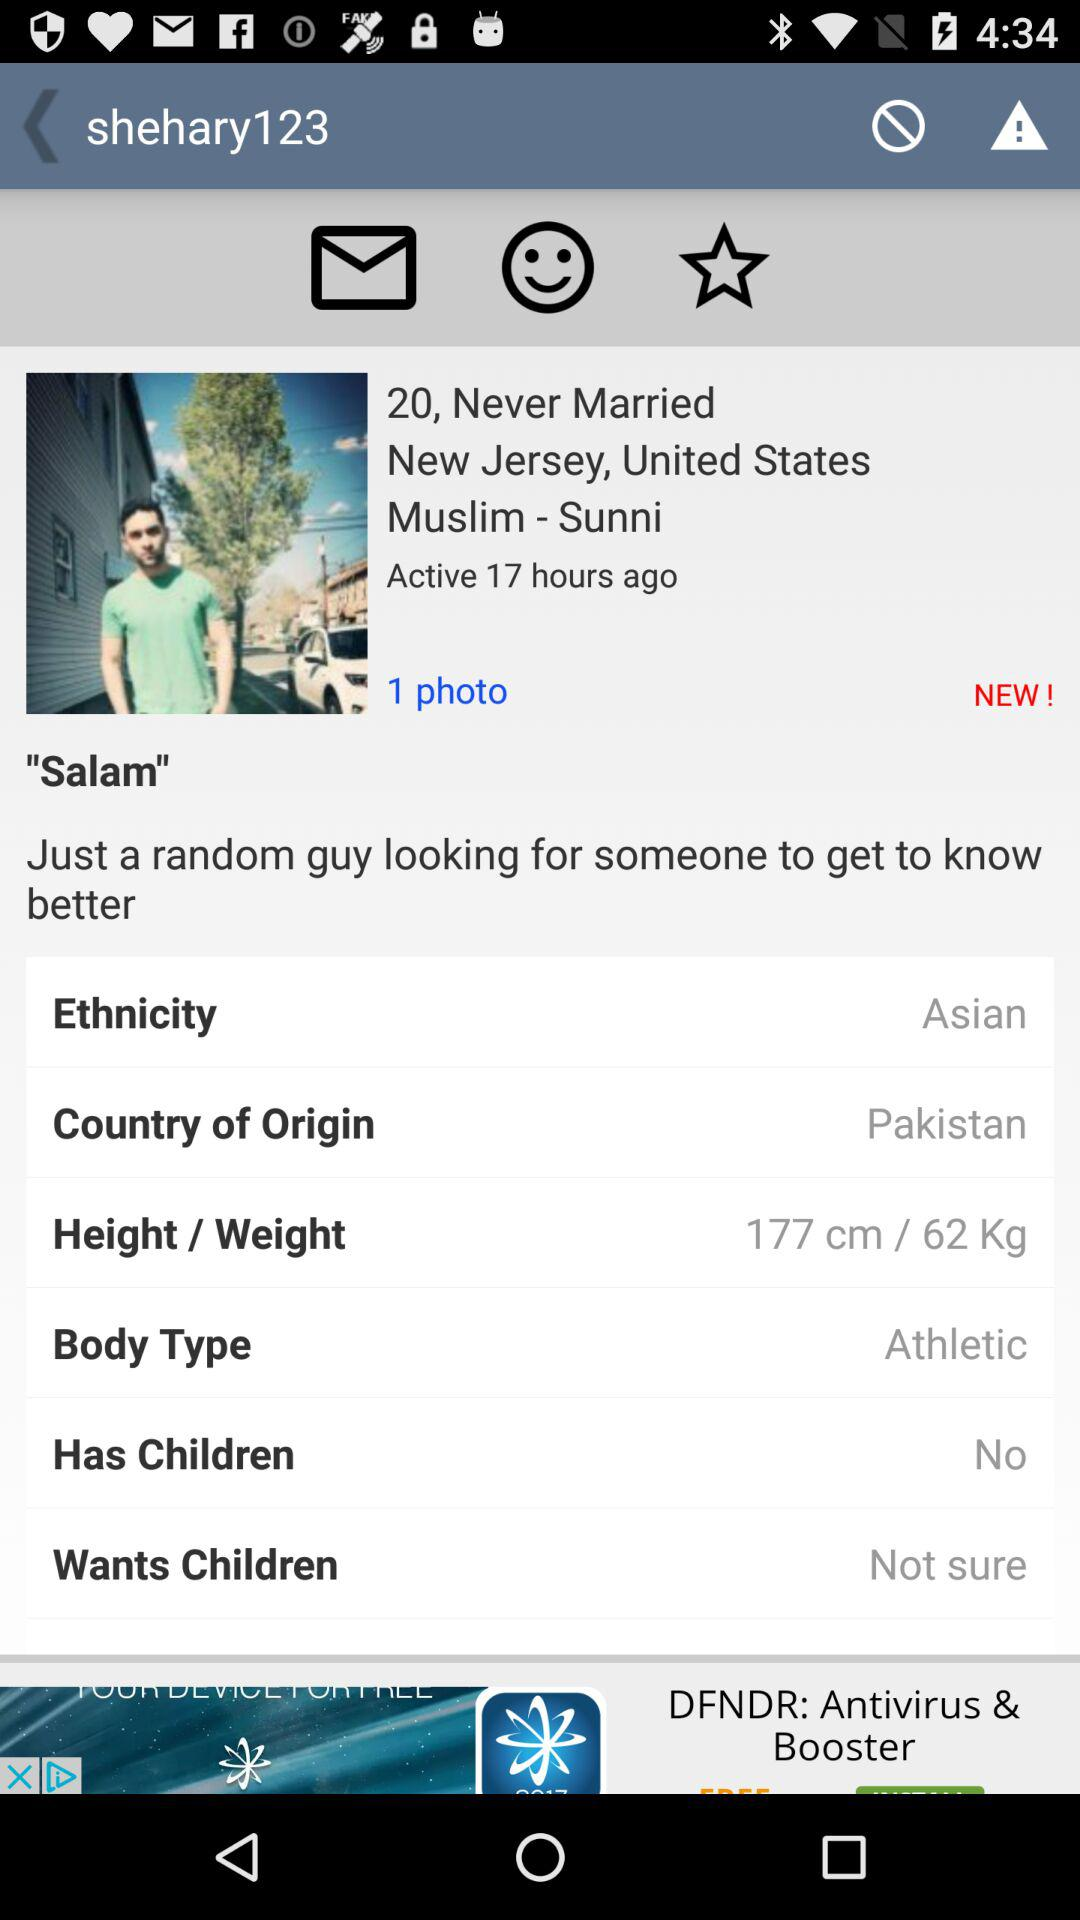What is the given body type? The given body type is "Athletic". 